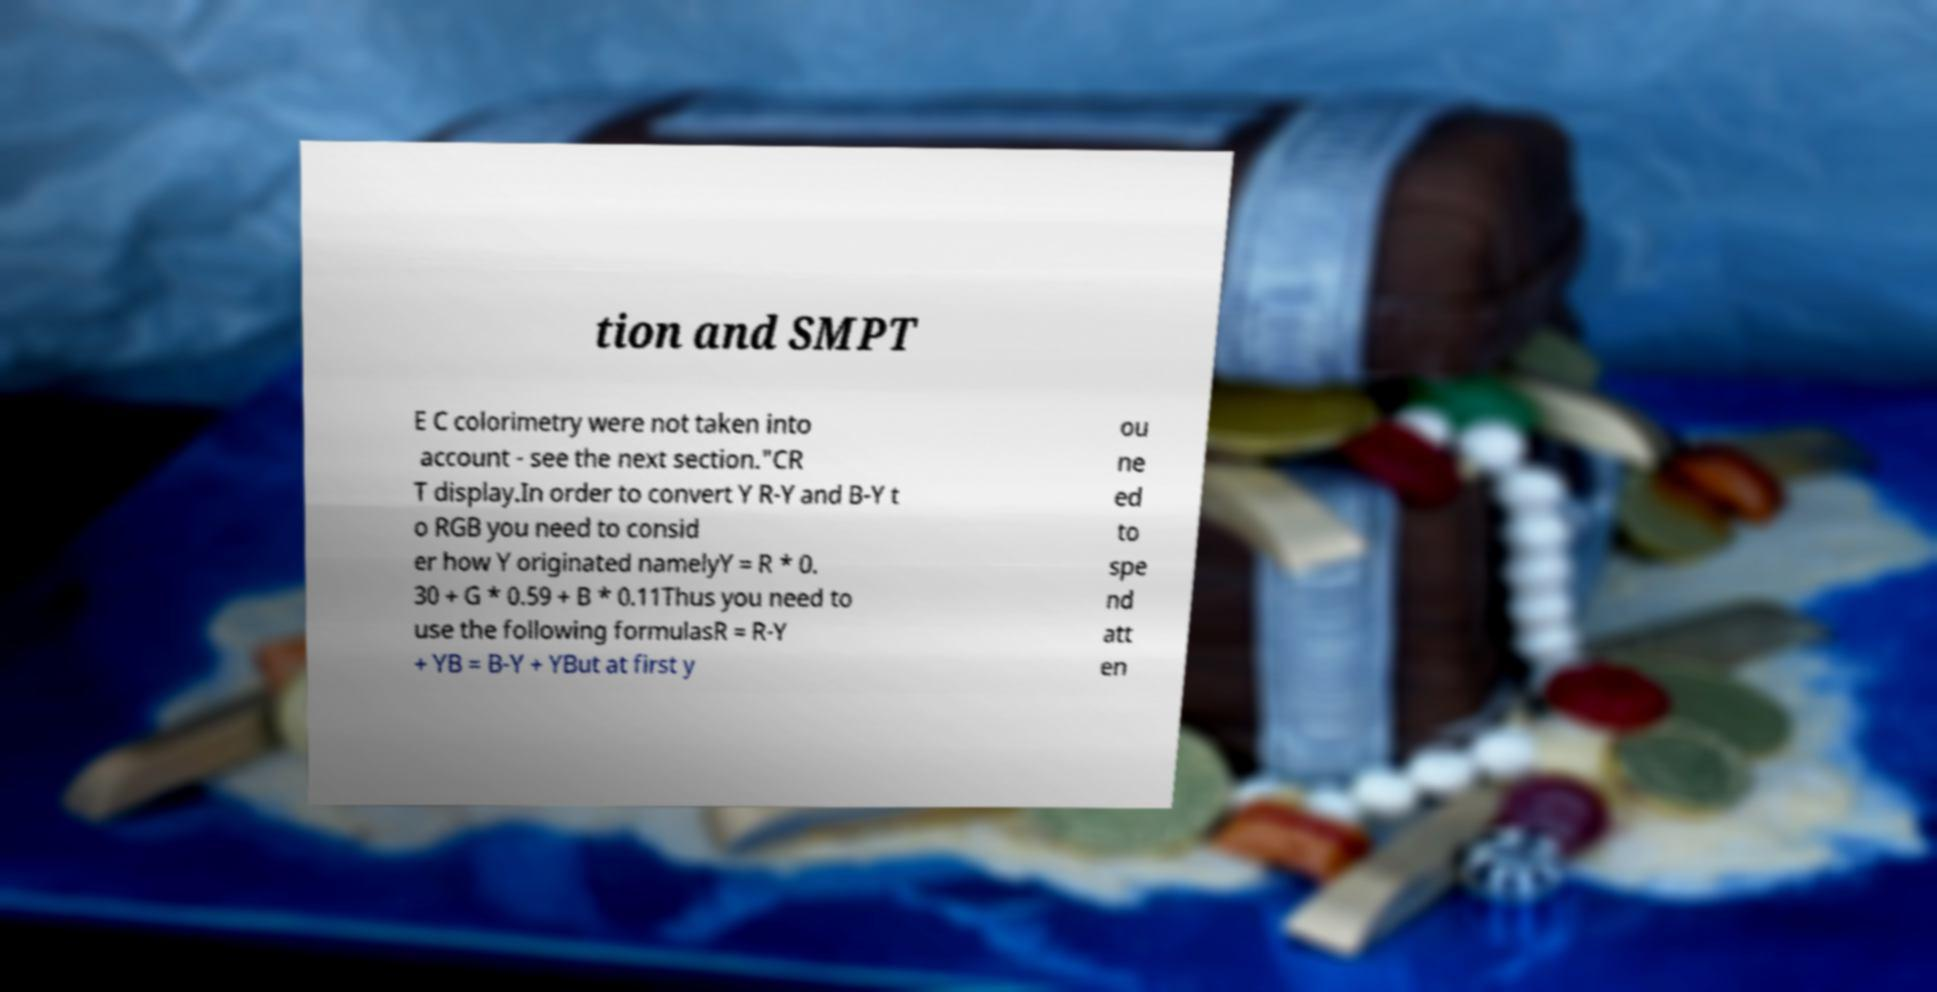For documentation purposes, I need the text within this image transcribed. Could you provide that? tion and SMPT E C colorimetry were not taken into account - see the next section."CR T display.In order to convert Y R-Y and B-Y t o RGB you need to consid er how Y originated namelyY = R * 0. 30 + G * 0.59 + B * 0.11Thus you need to use the following formulasR = R-Y + YB = B-Y + YBut at first y ou ne ed to spe nd att en 